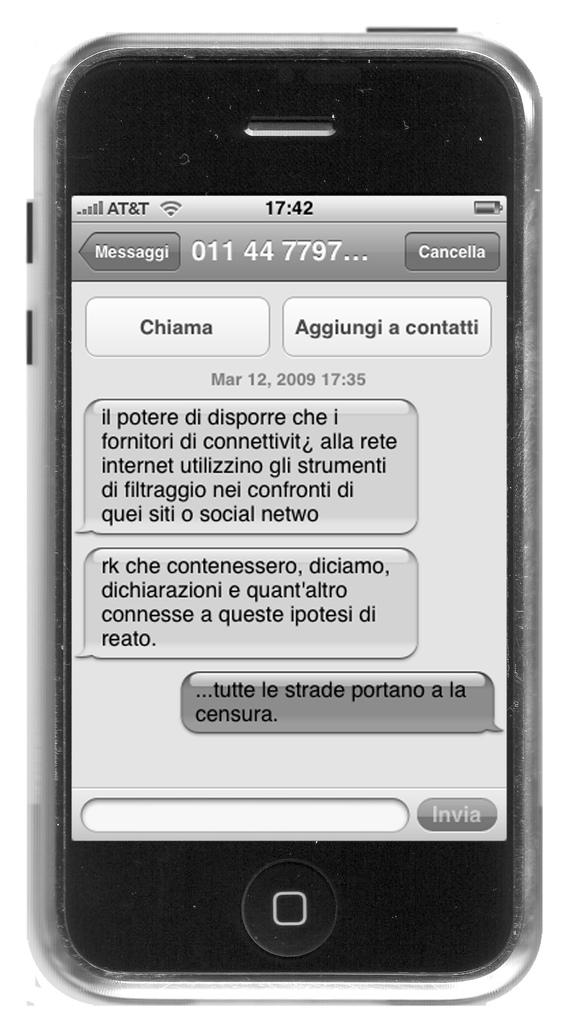<image>
Relay a brief, clear account of the picture shown. a mobile phone displaying a non English language, the word cancella is available top right 